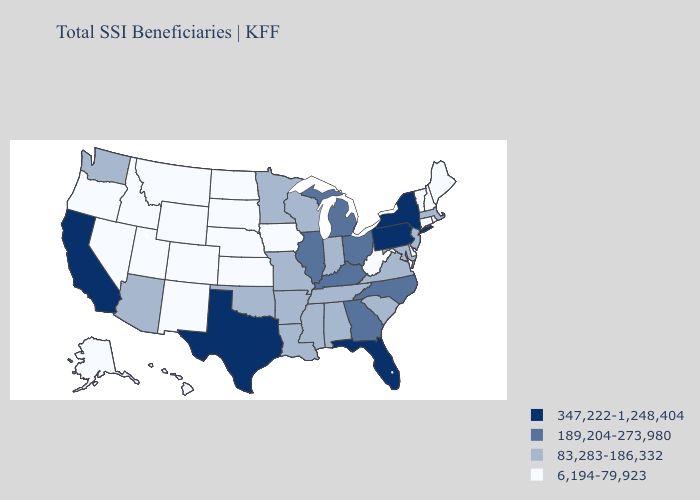Name the states that have a value in the range 347,222-1,248,404?
Answer briefly. California, Florida, New York, Pennsylvania, Texas. What is the value of Arkansas?
Answer briefly. 83,283-186,332. Does Virginia have the highest value in the South?
Write a very short answer. No. Name the states that have a value in the range 83,283-186,332?
Give a very brief answer. Alabama, Arizona, Arkansas, Indiana, Louisiana, Maryland, Massachusetts, Minnesota, Mississippi, Missouri, New Jersey, Oklahoma, South Carolina, Tennessee, Virginia, Washington, Wisconsin. Among the states that border Ohio , which have the highest value?
Give a very brief answer. Pennsylvania. Name the states that have a value in the range 347,222-1,248,404?
Concise answer only. California, Florida, New York, Pennsylvania, Texas. Does Washington have a higher value than New York?
Answer briefly. No. What is the lowest value in the MidWest?
Keep it brief. 6,194-79,923. Name the states that have a value in the range 83,283-186,332?
Give a very brief answer. Alabama, Arizona, Arkansas, Indiana, Louisiana, Maryland, Massachusetts, Minnesota, Mississippi, Missouri, New Jersey, Oklahoma, South Carolina, Tennessee, Virginia, Washington, Wisconsin. Among the states that border Mississippi , which have the lowest value?
Concise answer only. Alabama, Arkansas, Louisiana, Tennessee. Which states have the highest value in the USA?
Short answer required. California, Florida, New York, Pennsylvania, Texas. Does California have the highest value in the West?
Answer briefly. Yes. Name the states that have a value in the range 83,283-186,332?
Quick response, please. Alabama, Arizona, Arkansas, Indiana, Louisiana, Maryland, Massachusetts, Minnesota, Mississippi, Missouri, New Jersey, Oklahoma, South Carolina, Tennessee, Virginia, Washington, Wisconsin. What is the highest value in the USA?
Be succinct. 347,222-1,248,404. Does the map have missing data?
Short answer required. No. 